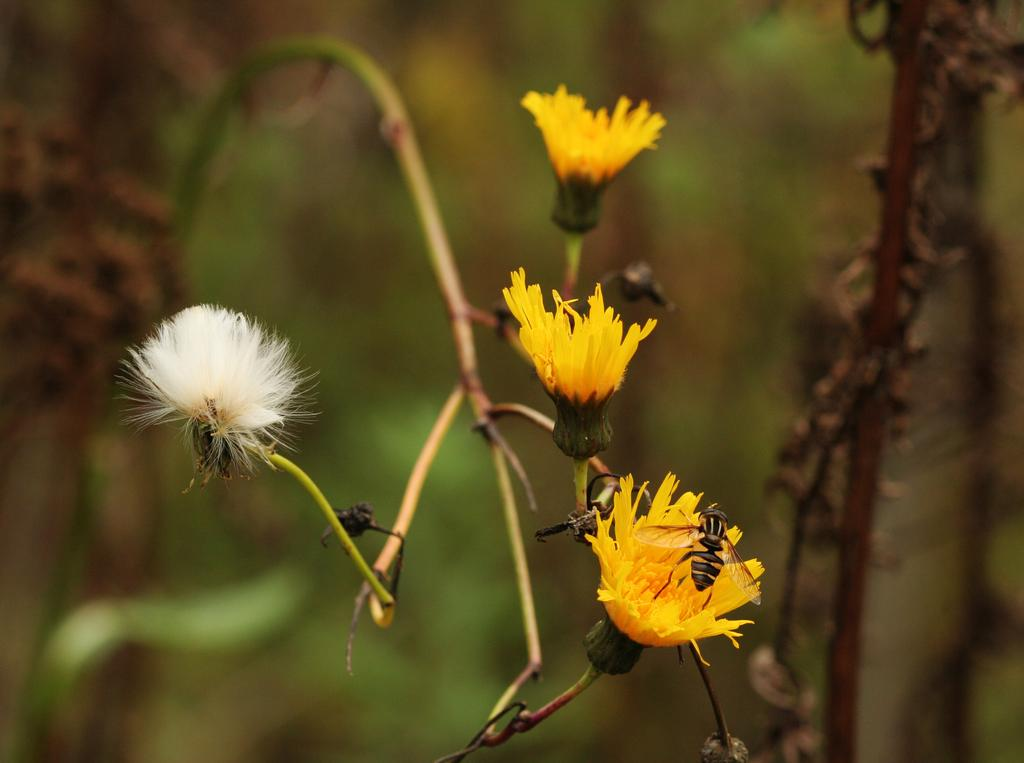What is present on the branch of the plant in the image? There are flowers on the branch of a plant in the image. Can you describe any additional details about the flowers? There is an insect on one of the flowers in the image. What type of knowledge can be gained from the downtown area in the image? There is no downtown area present in the image, so no knowledge can be gained from it. 